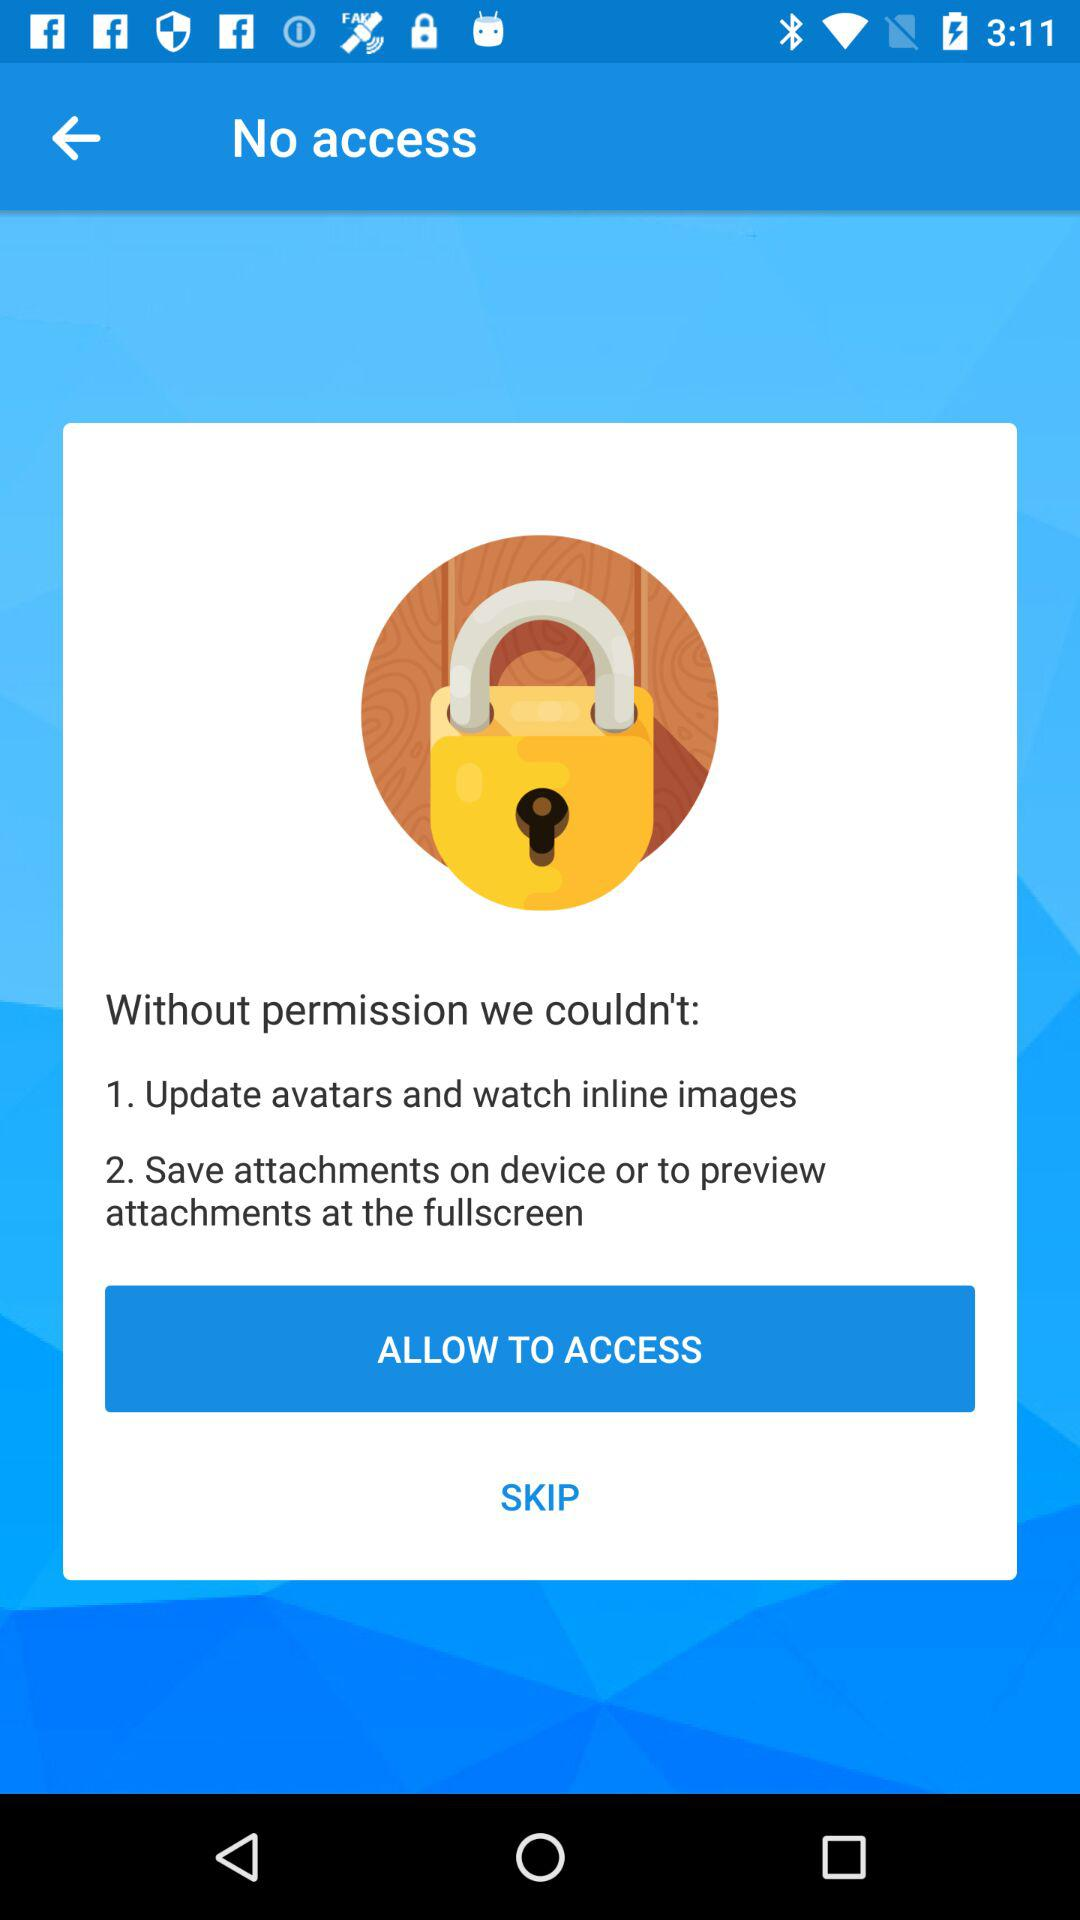What is the selected option?
When the provided information is insufficient, respond with <no answer>. <no answer> 